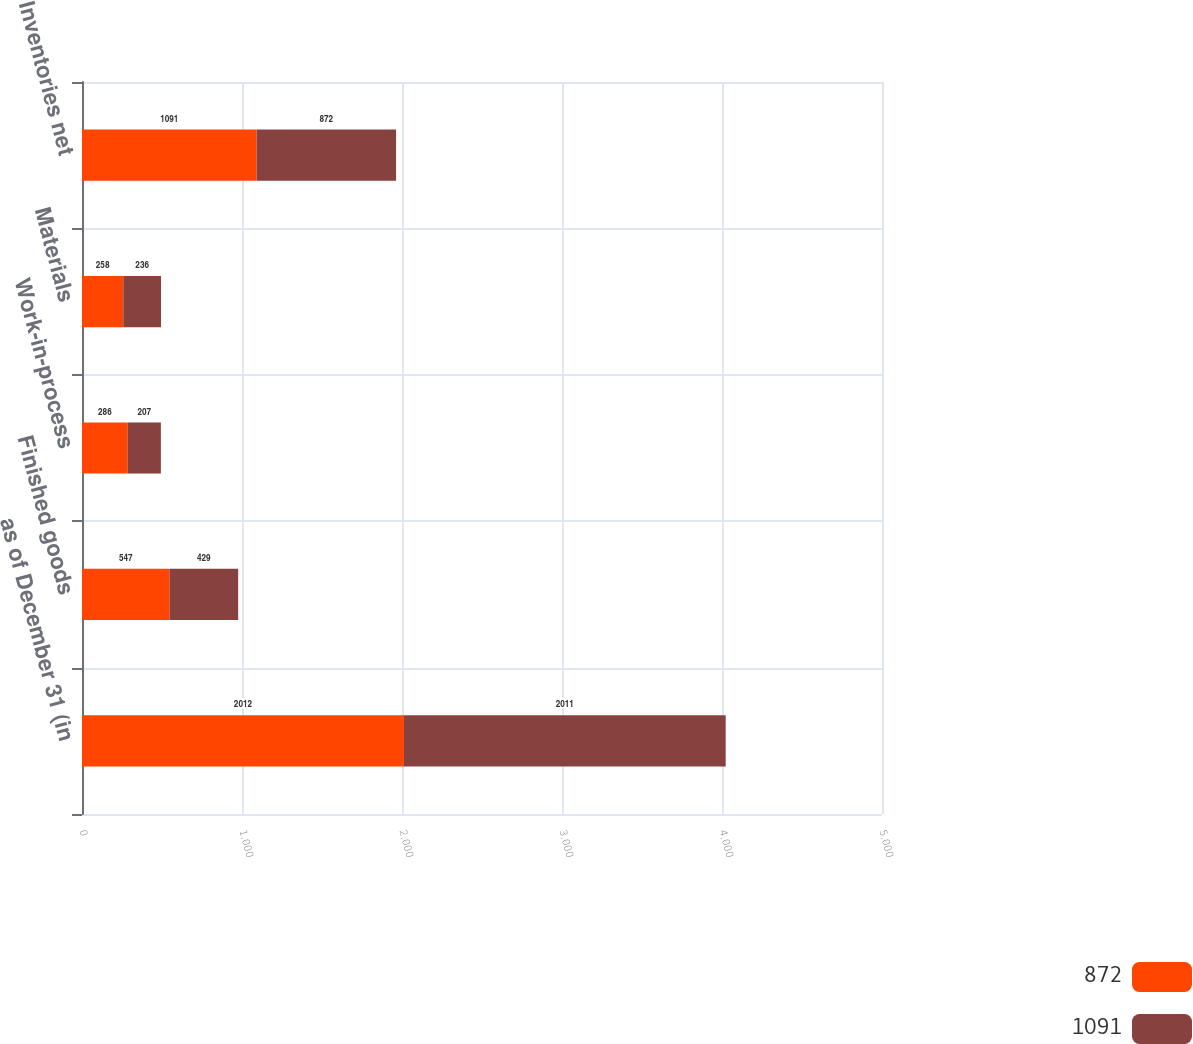Convert chart to OTSL. <chart><loc_0><loc_0><loc_500><loc_500><stacked_bar_chart><ecel><fcel>as of December 31 (in<fcel>Finished goods<fcel>Work-in-process<fcel>Materials<fcel>Inventories net<nl><fcel>872<fcel>2012<fcel>547<fcel>286<fcel>258<fcel>1091<nl><fcel>1091<fcel>2011<fcel>429<fcel>207<fcel>236<fcel>872<nl></chart> 